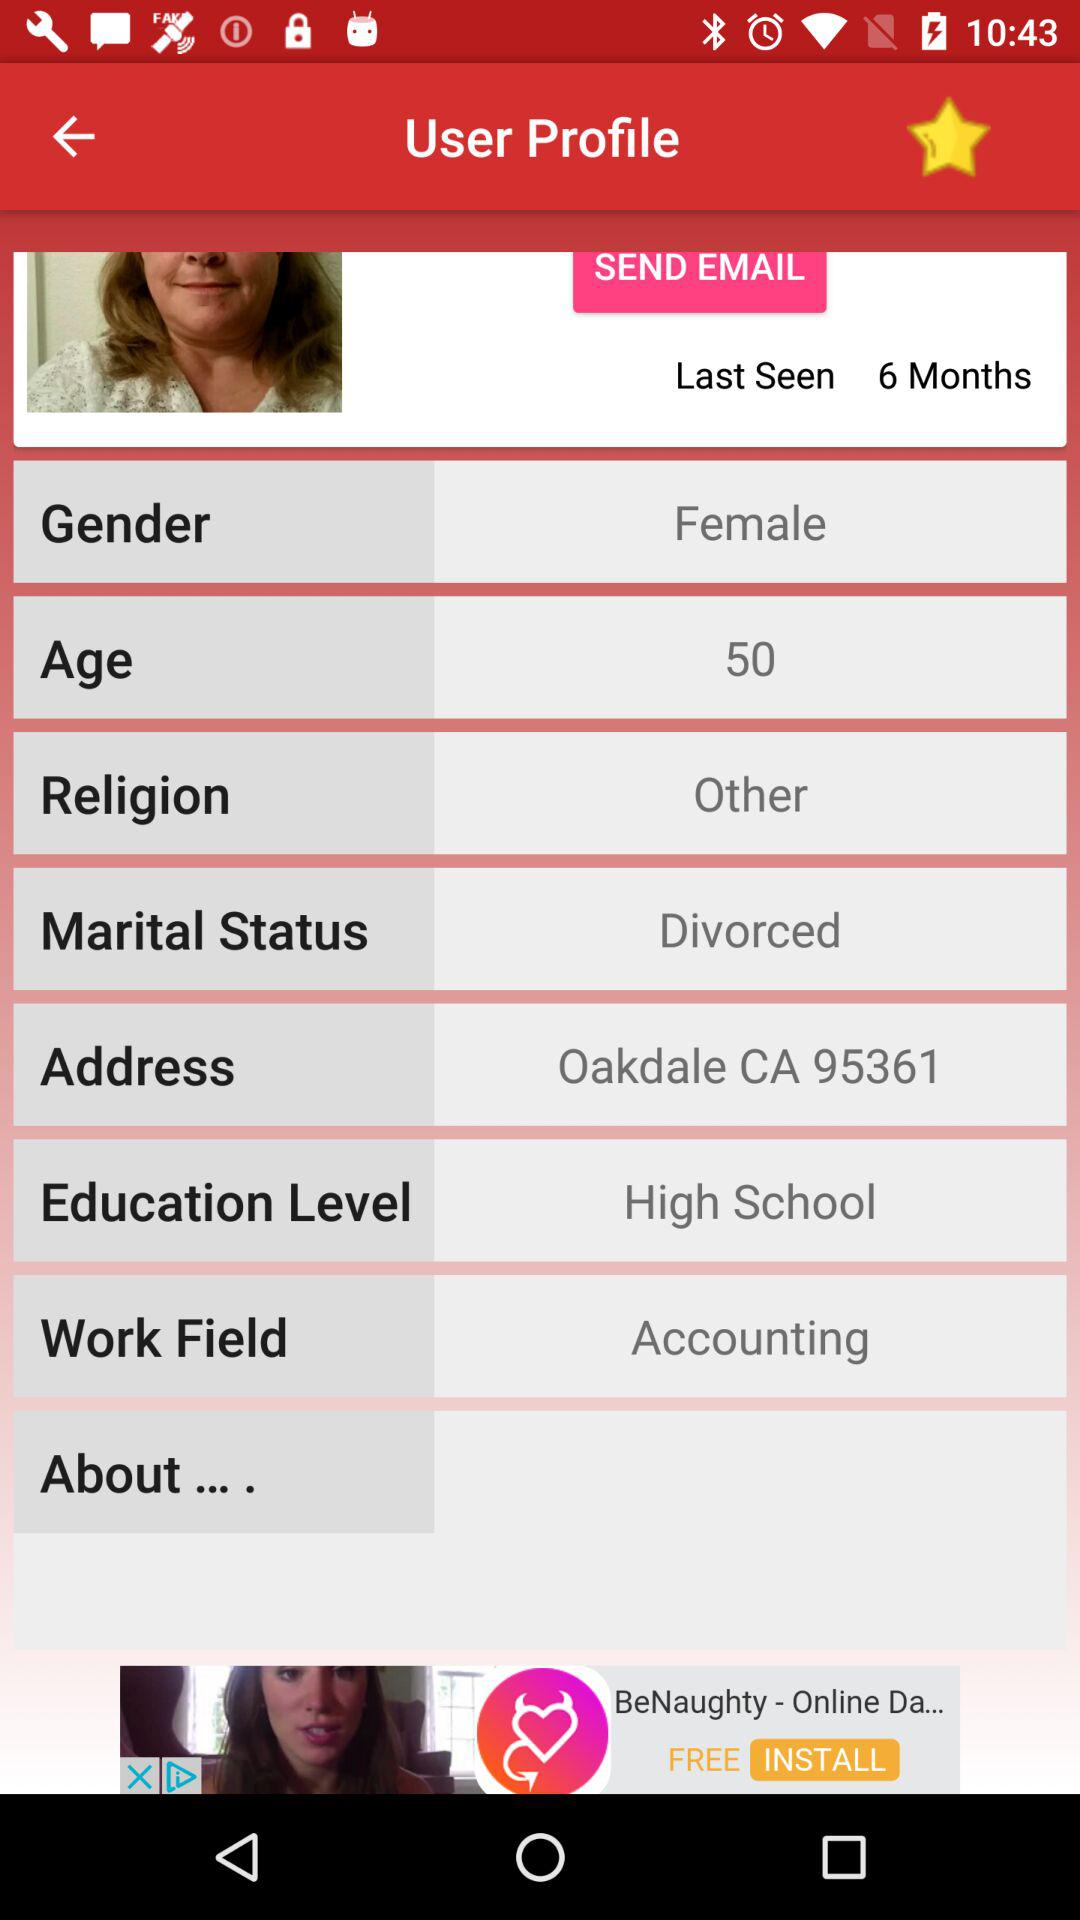Which religion does the user belong to? The religion is "Other". 